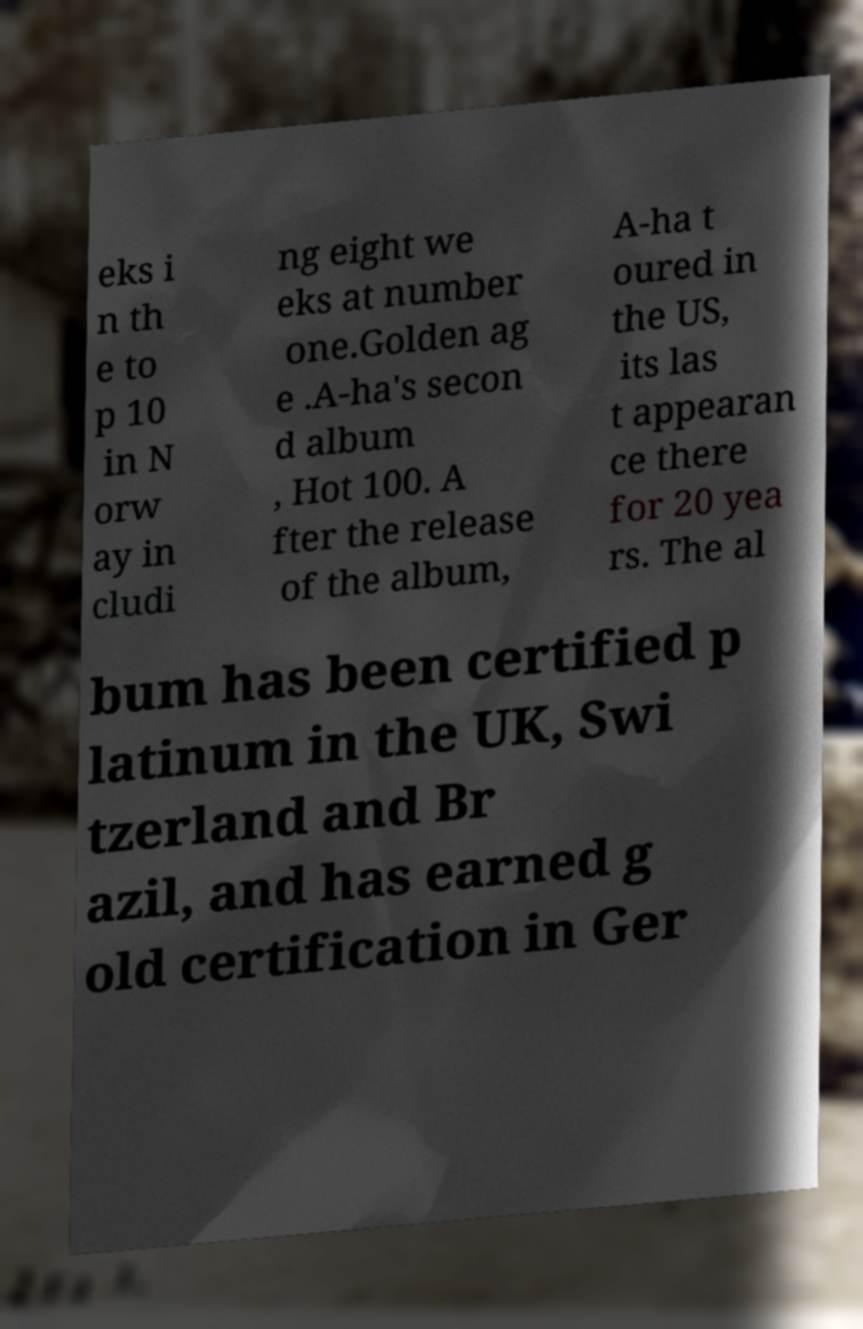What messages or text are displayed in this image? I need them in a readable, typed format. eks i n th e to p 10 in N orw ay in cludi ng eight we eks at number one.Golden ag e .A-ha's secon d album , Hot 100. A fter the release of the album, A-ha t oured in the US, its las t appearan ce there for 20 yea rs. The al bum has been certified p latinum in the UK, Swi tzerland and Br azil, and has earned g old certification in Ger 